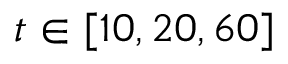Convert formula to latex. <formula><loc_0><loc_0><loc_500><loc_500>t \in [ 1 0 , 2 0 , 6 0 ]</formula> 